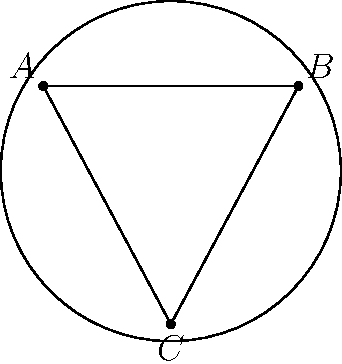In the Poincaré disk model of hyperbolic geometry shown above, triangle ABC is formed by three geodesics (blue arcs). If the sum of the interior angles ($\alpha + \beta + \gamma$) of this triangle is $\frac{\pi}{2}$, what is the area of this triangle in terms of $\pi$? To solve this problem, we'll use the Gauss-Bonnet formula for hyperbolic triangles:

1) In hyperbolic geometry, the area of a triangle is given by:
   $$ A = \pi - (\alpha + \beta + \gamma) $$
   Where $A$ is the area, and $\alpha$, $\beta$, and $\gamma$ are the interior angles of the triangle.

2) We're given that the sum of the interior angles is $\frac{\pi}{2}$:
   $$ \alpha + \beta + \gamma = \frac{\pi}{2} $$

3) Substituting this into the Gauss-Bonnet formula:
   $$ A = \pi - \frac{\pi}{2} $$

4) Simplifying:
   $$ A = \frac{\pi}{2} $$

5) Therefore, the area of the triangle is $\frac{\pi}{2}$.

This result illustrates a key difference between Euclidean and hyperbolic geometry. In Euclidean geometry, the sum of the angles in a triangle is always $\pi$, and the area of a triangle is independent of its angles. In hyperbolic geometry, the sum of the angles is always less than $\pi$, and the area of a triangle is directly related to its angles.
Answer: $\frac{\pi}{2}$ 